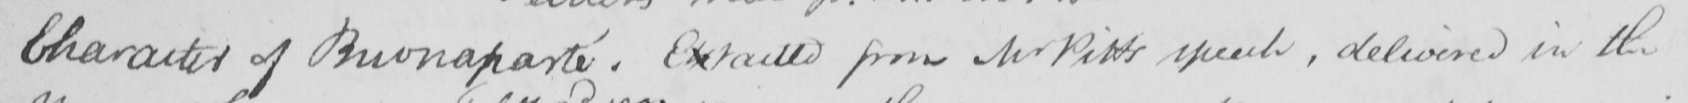What text is written in this handwritten line? Character of Buonaparte . Extracted from Mr Pitts speech , delivered in the 